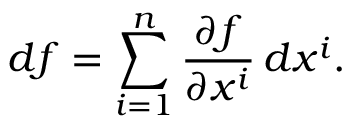Convert formula to latex. <formula><loc_0><loc_0><loc_500><loc_500>d f = \sum _ { i = 1 } ^ { n } { \frac { \partial f } { \partial x ^ { i } } } \, d x ^ { i } .</formula> 